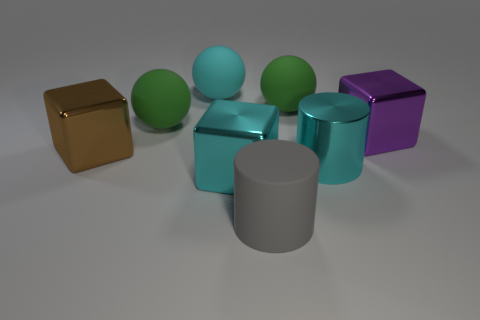Subtract all gray cylinders. How many green balls are left? 2 Subtract all cyan rubber spheres. How many spheres are left? 2 Add 1 big cyan shiny things. How many objects exist? 9 Subtract all cylinders. How many objects are left? 6 Subtract all blue blocks. Subtract all red cylinders. How many blocks are left? 3 Add 1 rubber cylinders. How many rubber cylinders exist? 2 Subtract 0 red cylinders. How many objects are left? 8 Subtract all big yellow objects. Subtract all large gray rubber objects. How many objects are left? 7 Add 2 gray matte cylinders. How many gray matte cylinders are left? 3 